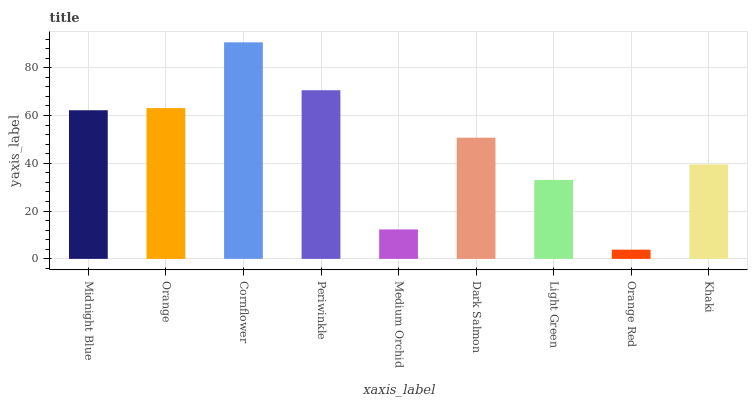Is Orange Red the minimum?
Answer yes or no. Yes. Is Cornflower the maximum?
Answer yes or no. Yes. Is Orange the minimum?
Answer yes or no. No. Is Orange the maximum?
Answer yes or no. No. Is Orange greater than Midnight Blue?
Answer yes or no. Yes. Is Midnight Blue less than Orange?
Answer yes or no. Yes. Is Midnight Blue greater than Orange?
Answer yes or no. No. Is Orange less than Midnight Blue?
Answer yes or no. No. Is Dark Salmon the high median?
Answer yes or no. Yes. Is Dark Salmon the low median?
Answer yes or no. Yes. Is Light Green the high median?
Answer yes or no. No. Is Orange the low median?
Answer yes or no. No. 